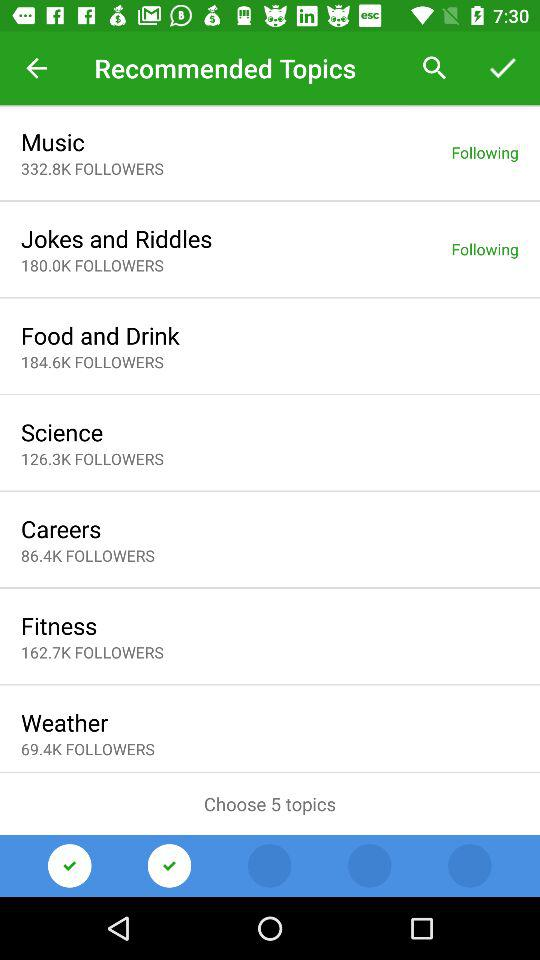How many followers are there for fitness? There are 162.7K followers. 